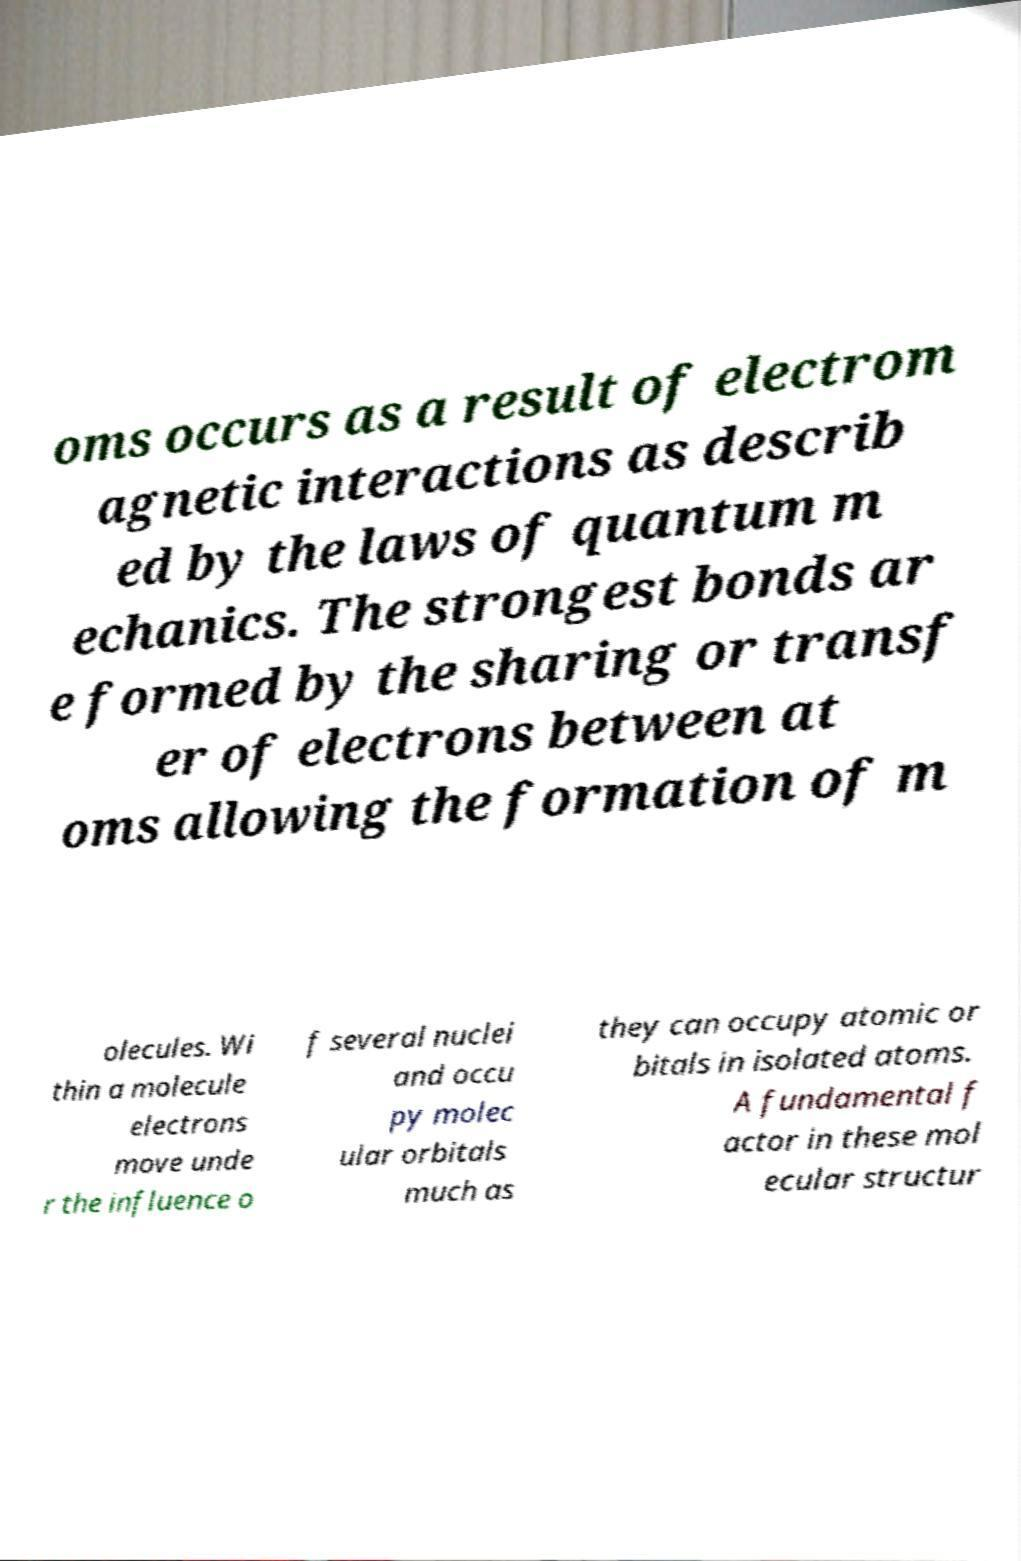Can you accurately transcribe the text from the provided image for me? oms occurs as a result of electrom agnetic interactions as describ ed by the laws of quantum m echanics. The strongest bonds ar e formed by the sharing or transf er of electrons between at oms allowing the formation of m olecules. Wi thin a molecule electrons move unde r the influence o f several nuclei and occu py molec ular orbitals much as they can occupy atomic or bitals in isolated atoms. A fundamental f actor in these mol ecular structur 